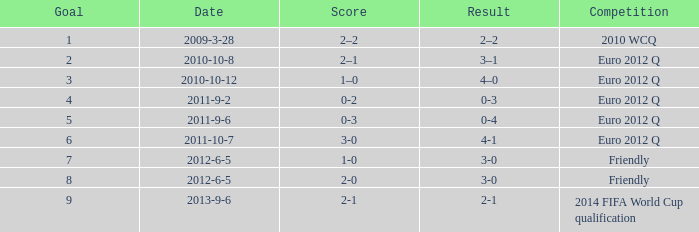What happens when the score reaches 0-2? 0-3. 